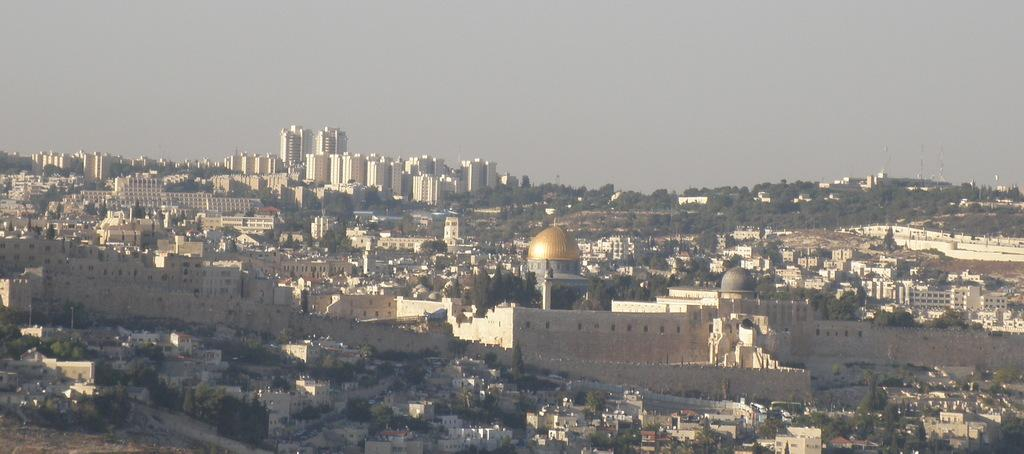What type of location might the image be taken from? The image might be taken from a hilly area. What structures can be seen in the image? There are buildings and towers in the image. What type of vegetation is present in the image? There are trees in the image. What is visible at the top of the image? The sky is visible at the top of the image. What is the rate of the cent in the image? There is no cent or any reference to a rate in the image. 